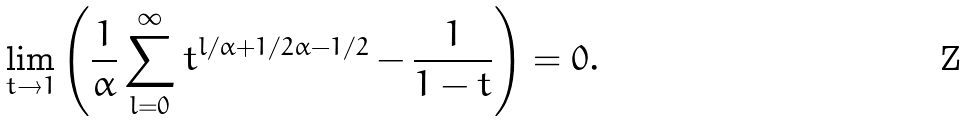<formula> <loc_0><loc_0><loc_500><loc_500>\lim _ { t \to 1 } \left ( \frac { 1 } { \alpha } \sum _ { l = 0 } ^ { \infty } t ^ { l / \alpha + 1 / 2 \alpha - 1 / 2 } - \frac { 1 } { 1 - t } \right ) = 0 .</formula> 